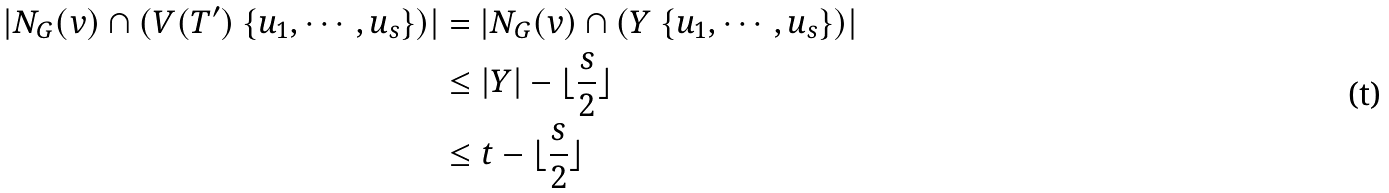Convert formula to latex. <formula><loc_0><loc_0><loc_500><loc_500>| N _ { G } ( v ) \cap ( V ( T ^ { \prime } ) \ \{ u _ { 1 } , \cdots , u _ { s } \} ) | & = | N _ { G } ( v ) \cap ( Y \ \{ u _ { 1 } , \cdots , u _ { s } \} ) | \\ & \leq | Y | - \lfloor \frac { s } { 2 } \rfloor \\ & \leq t - \lfloor \frac { s } { 2 } \rfloor</formula> 